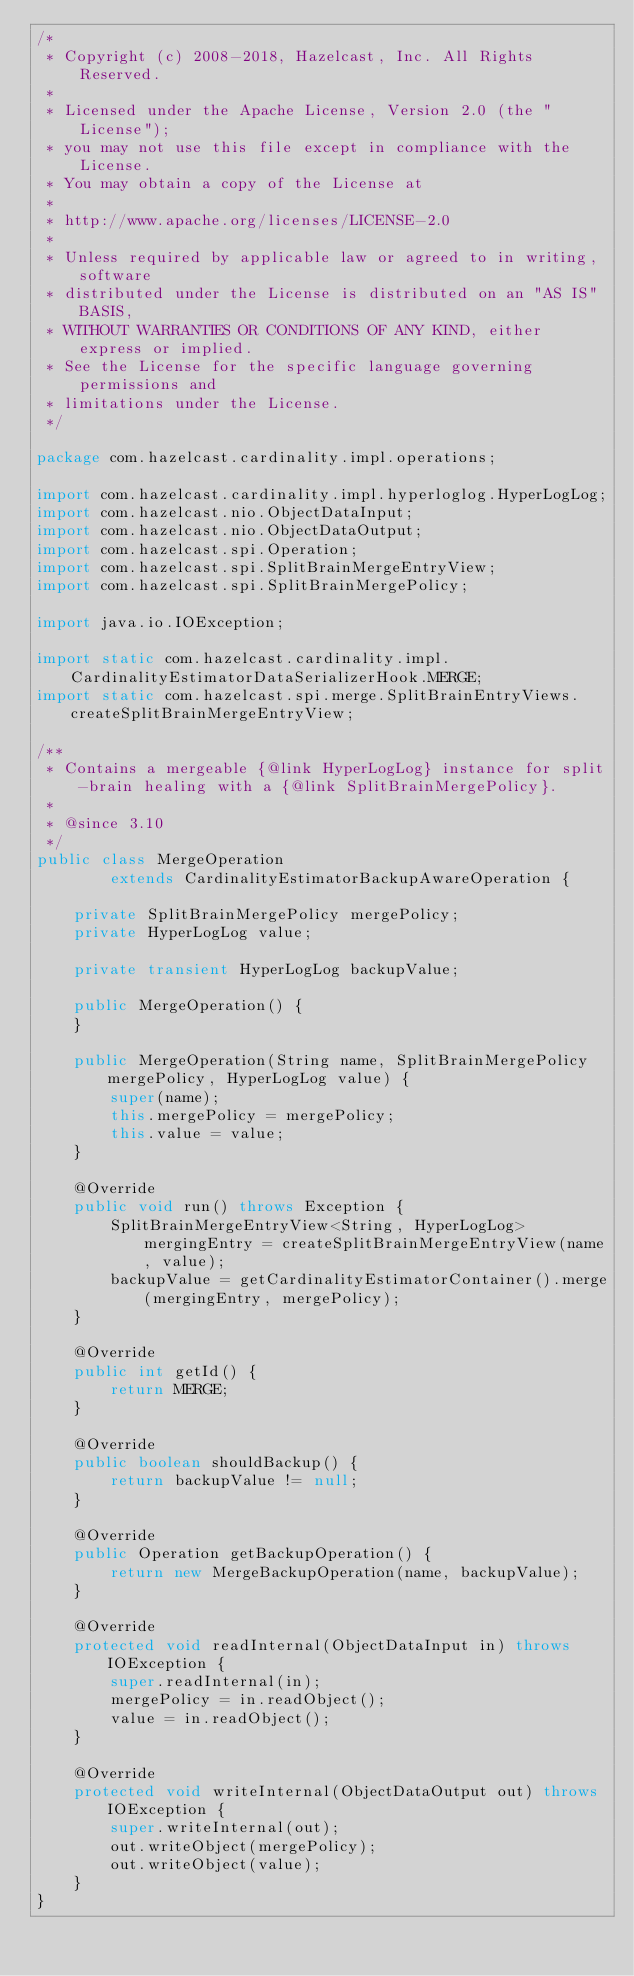Convert code to text. <code><loc_0><loc_0><loc_500><loc_500><_Java_>/*
 * Copyright (c) 2008-2018, Hazelcast, Inc. All Rights Reserved.
 *
 * Licensed under the Apache License, Version 2.0 (the "License");
 * you may not use this file except in compliance with the License.
 * You may obtain a copy of the License at
 *
 * http://www.apache.org/licenses/LICENSE-2.0
 *
 * Unless required by applicable law or agreed to in writing, software
 * distributed under the License is distributed on an "AS IS" BASIS,
 * WITHOUT WARRANTIES OR CONDITIONS OF ANY KIND, either express or implied.
 * See the License for the specific language governing permissions and
 * limitations under the License.
 */

package com.hazelcast.cardinality.impl.operations;

import com.hazelcast.cardinality.impl.hyperloglog.HyperLogLog;
import com.hazelcast.nio.ObjectDataInput;
import com.hazelcast.nio.ObjectDataOutput;
import com.hazelcast.spi.Operation;
import com.hazelcast.spi.SplitBrainMergeEntryView;
import com.hazelcast.spi.SplitBrainMergePolicy;

import java.io.IOException;

import static com.hazelcast.cardinality.impl.CardinalityEstimatorDataSerializerHook.MERGE;
import static com.hazelcast.spi.merge.SplitBrainEntryViews.createSplitBrainMergeEntryView;

/**
 * Contains a mergeable {@link HyperLogLog} instance for split-brain healing with a {@link SplitBrainMergePolicy}.
 *
 * @since 3.10
 */
public class MergeOperation
        extends CardinalityEstimatorBackupAwareOperation {

    private SplitBrainMergePolicy mergePolicy;
    private HyperLogLog value;

    private transient HyperLogLog backupValue;

    public MergeOperation() {
    }

    public MergeOperation(String name, SplitBrainMergePolicy mergePolicy, HyperLogLog value) {
        super(name);
        this.mergePolicy = mergePolicy;
        this.value = value;
    }

    @Override
    public void run() throws Exception {
        SplitBrainMergeEntryView<String, HyperLogLog> mergingEntry = createSplitBrainMergeEntryView(name, value);
        backupValue = getCardinalityEstimatorContainer().merge(mergingEntry, mergePolicy);
    }

    @Override
    public int getId() {
        return MERGE;
    }

    @Override
    public boolean shouldBackup() {
        return backupValue != null;
    }

    @Override
    public Operation getBackupOperation() {
        return new MergeBackupOperation(name, backupValue);
    }

    @Override
    protected void readInternal(ObjectDataInput in) throws IOException {
        super.readInternal(in);
        mergePolicy = in.readObject();
        value = in.readObject();
    }

    @Override
    protected void writeInternal(ObjectDataOutput out) throws IOException {
        super.writeInternal(out);
        out.writeObject(mergePolicy);
        out.writeObject(value);
    }
}
</code> 